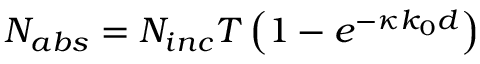Convert formula to latex. <formula><loc_0><loc_0><loc_500><loc_500>N _ { a b s } = N _ { i n c } T \left ( 1 - e ^ { - \kappa k _ { 0 } d } \right )</formula> 